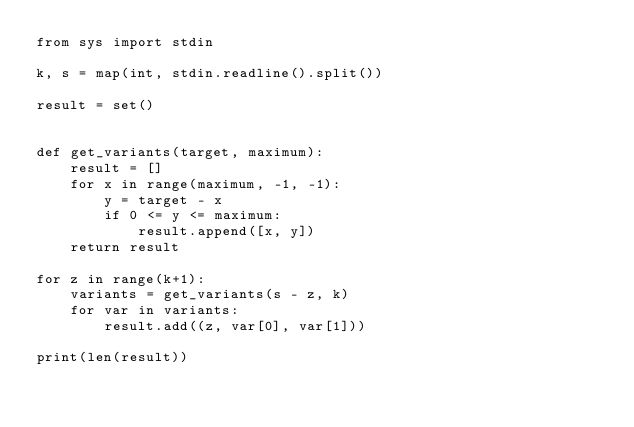Convert code to text. <code><loc_0><loc_0><loc_500><loc_500><_Python_>from sys import stdin

k, s = map(int, stdin.readline().split())

result = set()


def get_variants(target, maximum):
    result = []
    for x in range(maximum, -1, -1):
        y = target - x
        if 0 <= y <= maximum:
            result.append([x, y])
    return result

for z in range(k+1):
    variants = get_variants(s - z, k)
    for var in variants:
        result.add((z, var[0], var[1]))

print(len(result))
</code> 